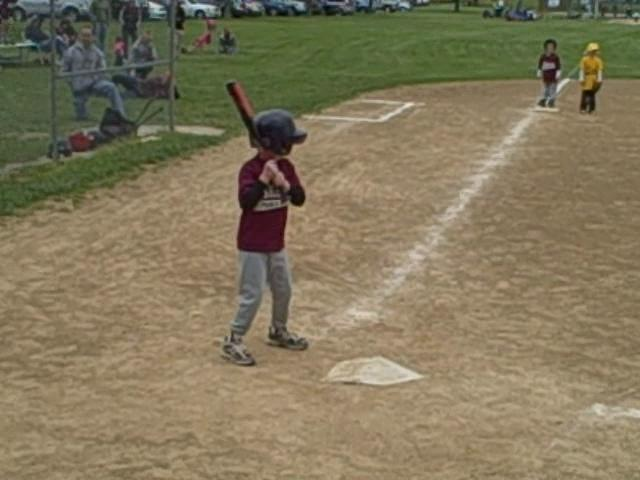What position does the player wearing yellow play?

Choices:
A) shortstop
B) third base
C) pitcher
D) catcher third base 